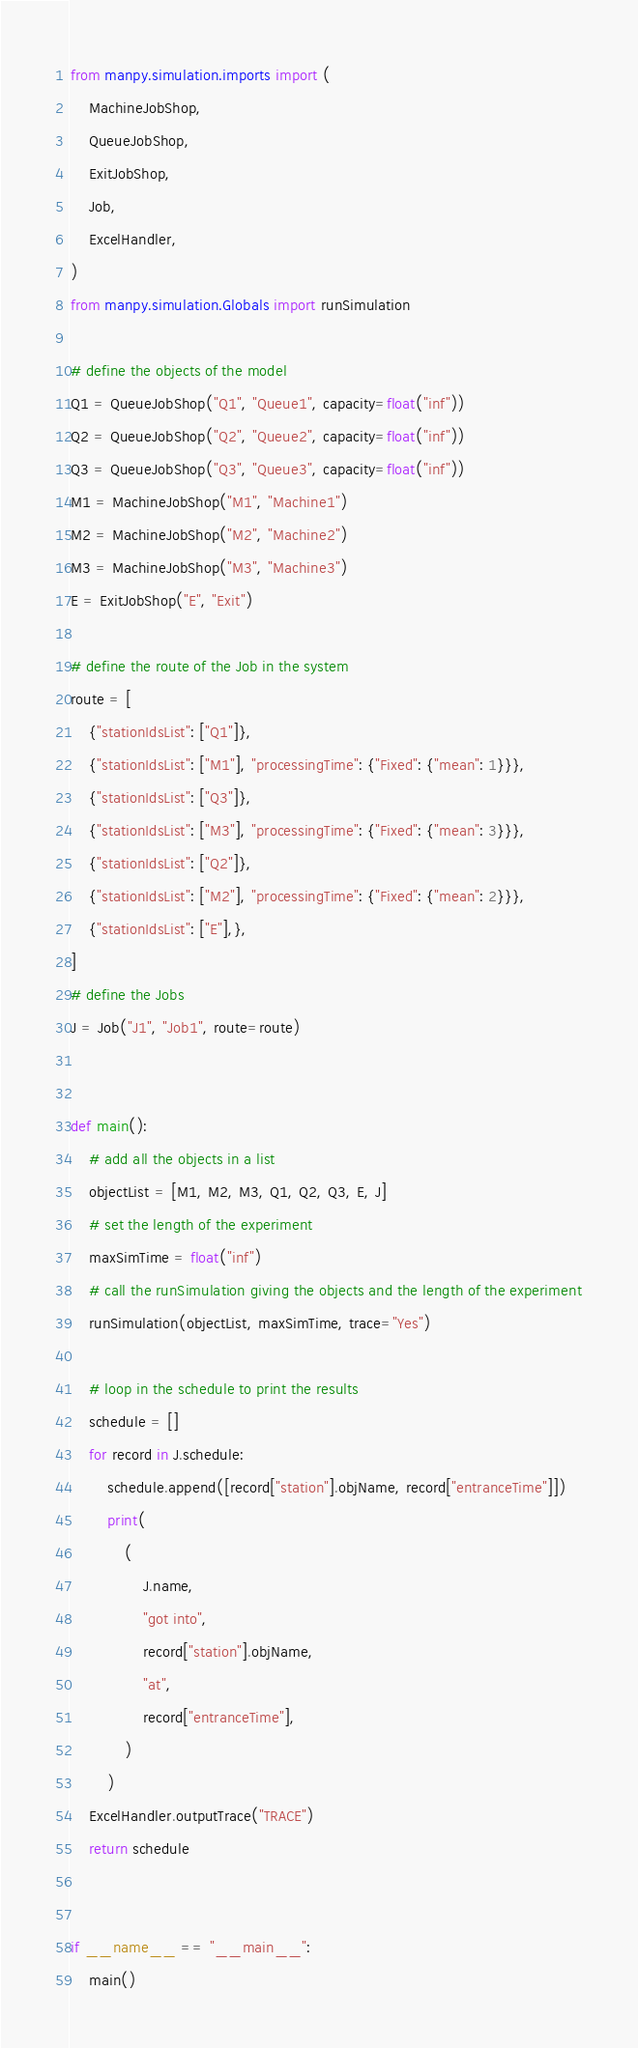Convert code to text. <code><loc_0><loc_0><loc_500><loc_500><_Python_>from manpy.simulation.imports import (
    MachineJobShop,
    QueueJobShop,
    ExitJobShop,
    Job,
    ExcelHandler,
)
from manpy.simulation.Globals import runSimulation

# define the objects of the model
Q1 = QueueJobShop("Q1", "Queue1", capacity=float("inf"))
Q2 = QueueJobShop("Q2", "Queue2", capacity=float("inf"))
Q3 = QueueJobShop("Q3", "Queue3", capacity=float("inf"))
M1 = MachineJobShop("M1", "Machine1")
M2 = MachineJobShop("M2", "Machine2")
M3 = MachineJobShop("M3", "Machine3")
E = ExitJobShop("E", "Exit")

# define the route of the Job in the system
route = [
    {"stationIdsList": ["Q1"]},
    {"stationIdsList": ["M1"], "processingTime": {"Fixed": {"mean": 1}}},
    {"stationIdsList": ["Q3"]},
    {"stationIdsList": ["M3"], "processingTime": {"Fixed": {"mean": 3}}},
    {"stationIdsList": ["Q2"]},
    {"stationIdsList": ["M2"], "processingTime": {"Fixed": {"mean": 2}}},
    {"stationIdsList": ["E"],},
]
# define the Jobs
J = Job("J1", "Job1", route=route)


def main():
    # add all the objects in a list
    objectList = [M1, M2, M3, Q1, Q2, Q3, E, J]
    # set the length of the experiment
    maxSimTime = float("inf")
    # call the runSimulation giving the objects and the length of the experiment
    runSimulation(objectList, maxSimTime, trace="Yes")

    # loop in the schedule to print the results
    schedule = []
    for record in J.schedule:
        schedule.append([record["station"].objName, record["entranceTime"]])
        print(
            (
                J.name,
                "got into",
                record["station"].objName,
                "at",
                record["entranceTime"],
            )
        )
    ExcelHandler.outputTrace("TRACE")
    return schedule


if __name__ == "__main__":
    main()
</code> 